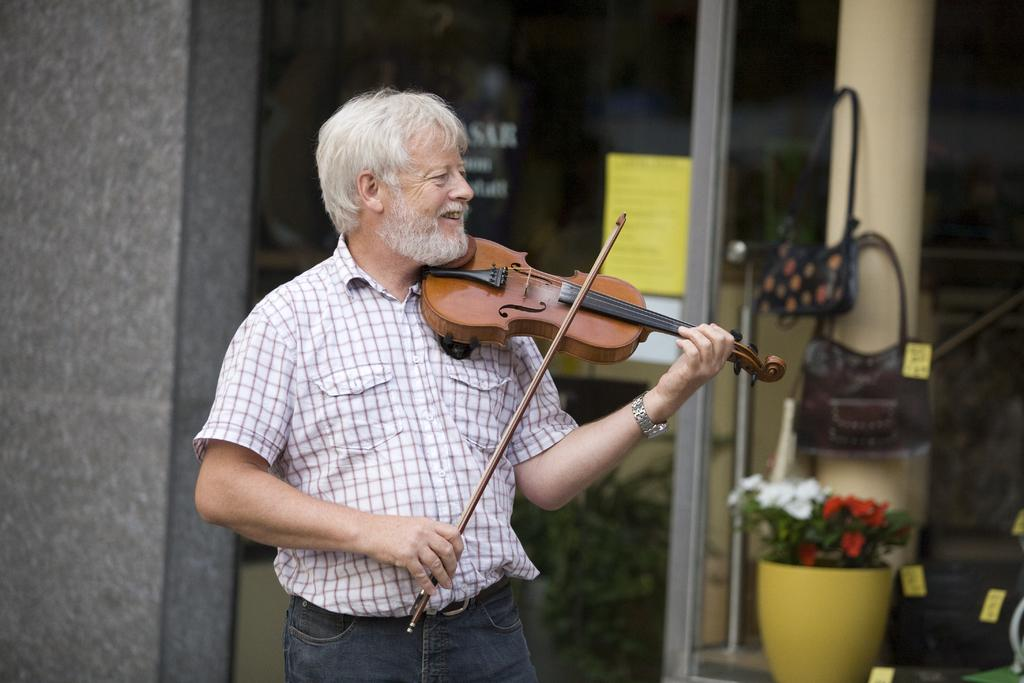Who is present in the image? There is a person in the image. What is the person wearing? The person is wearing a white shirt. What is the person doing in the image? The person is playing a violin. What can be seen in the background of the image? There is a house in the background of the image. What type of beast can be seen roaming around in the image? There is no beast present in the image; it features a person playing a violin. Are there any dinosaurs visible in the image? There are no dinosaurs present in the image. 